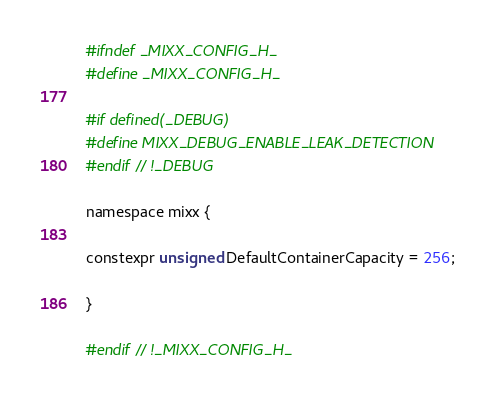<code> <loc_0><loc_0><loc_500><loc_500><_C_>#ifndef _MIXX_CONFIG_H_
#define _MIXX_CONFIG_H_

#if defined(_DEBUG)
#define MIXX_DEBUG_ENABLE_LEAK_DETECTION
#endif // !_DEBUG

namespace mixx {

constexpr unsigned DefaultContainerCapacity = 256;

}

#endif // !_MIXX_CONFIG_H_
</code> 